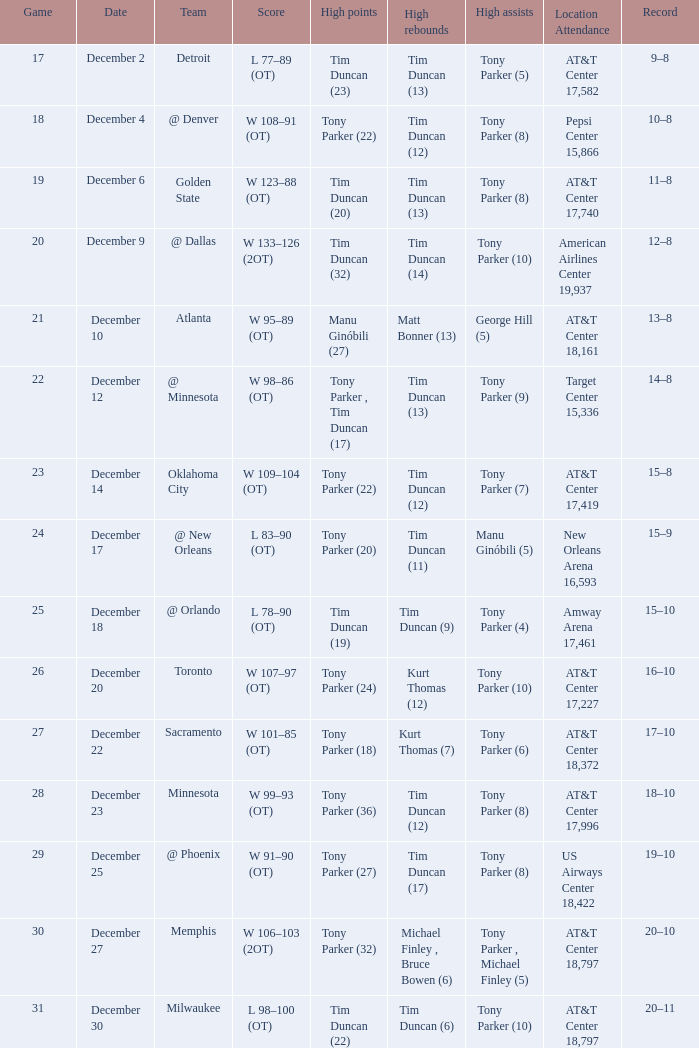What is tim duncan's (14) best score for rebounds? W 133–126 (2OT). 